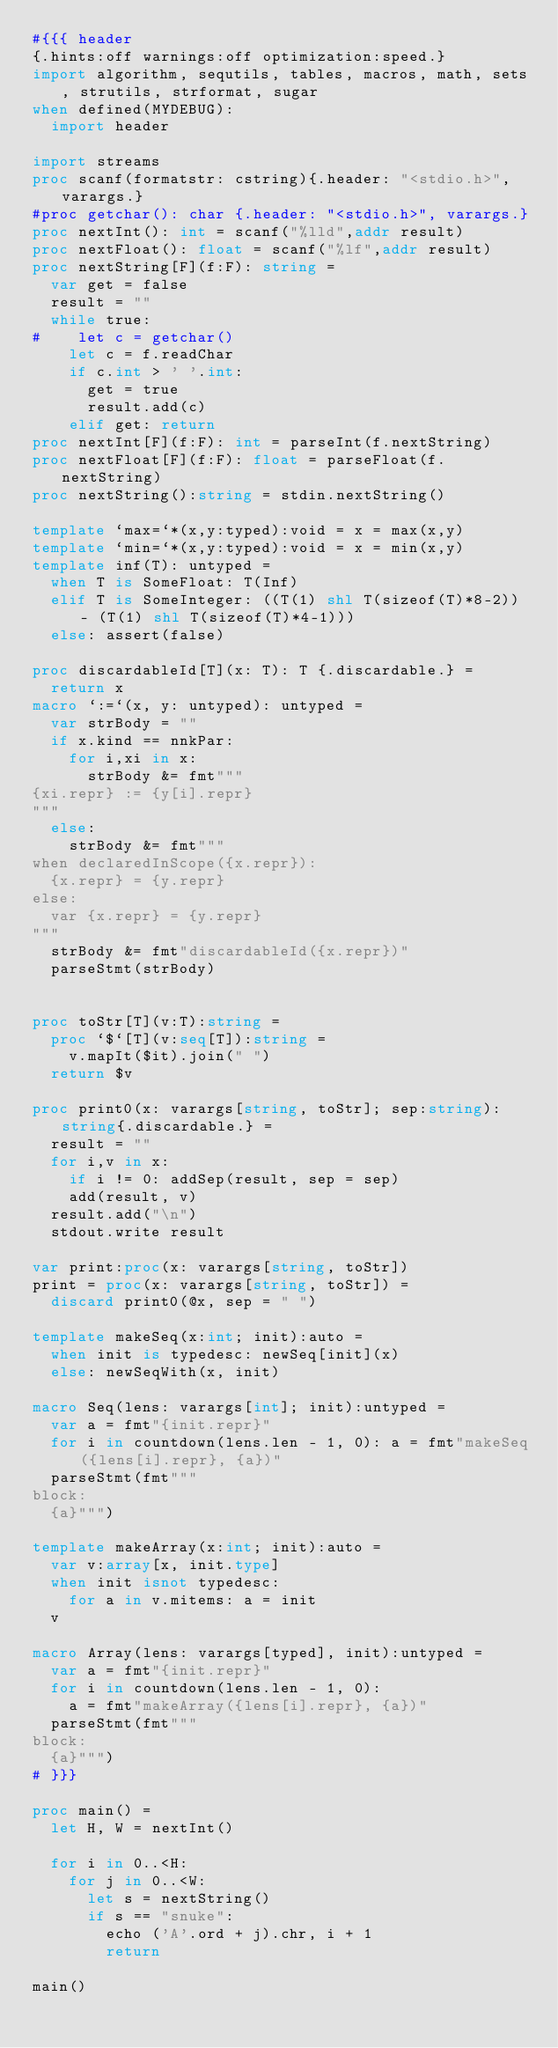Convert code to text. <code><loc_0><loc_0><loc_500><loc_500><_Nim_>#{{{ header
{.hints:off warnings:off optimization:speed.}
import algorithm, sequtils, tables, macros, math, sets, strutils, strformat, sugar
when defined(MYDEBUG):
  import header

import streams
proc scanf(formatstr: cstring){.header: "<stdio.h>", varargs.}
#proc getchar(): char {.header: "<stdio.h>", varargs.}
proc nextInt(): int = scanf("%lld",addr result)
proc nextFloat(): float = scanf("%lf",addr result)
proc nextString[F](f:F): string =
  var get = false
  result = ""
  while true:
#    let c = getchar()
    let c = f.readChar
    if c.int > ' '.int:
      get = true
      result.add(c)
    elif get: return
proc nextInt[F](f:F): int = parseInt(f.nextString)
proc nextFloat[F](f:F): float = parseFloat(f.nextString)
proc nextString():string = stdin.nextString()

template `max=`*(x,y:typed):void = x = max(x,y)
template `min=`*(x,y:typed):void = x = min(x,y)
template inf(T): untyped = 
  when T is SomeFloat: T(Inf)
  elif T is SomeInteger: ((T(1) shl T(sizeof(T)*8-2)) - (T(1) shl T(sizeof(T)*4-1)))
  else: assert(false)

proc discardableId[T](x: T): T {.discardable.} =
  return x
macro `:=`(x, y: untyped): untyped =
  var strBody = ""
  if x.kind == nnkPar:
    for i,xi in x:
      strBody &= fmt"""
{xi.repr} := {y[i].repr}
"""
  else:
    strBody &= fmt"""
when declaredInScope({x.repr}):
  {x.repr} = {y.repr}
else:
  var {x.repr} = {y.repr}
"""
  strBody &= fmt"discardableId({x.repr})"
  parseStmt(strBody)


proc toStr[T](v:T):string =
  proc `$`[T](v:seq[T]):string =
    v.mapIt($it).join(" ")
  return $v

proc print0(x: varargs[string, toStr]; sep:string):string{.discardable.} =
  result = ""
  for i,v in x:
    if i != 0: addSep(result, sep = sep)
    add(result, v)
  result.add("\n")
  stdout.write result

var print:proc(x: varargs[string, toStr])
print = proc(x: varargs[string, toStr]) =
  discard print0(@x, sep = " ")

template makeSeq(x:int; init):auto =
  when init is typedesc: newSeq[init](x)
  else: newSeqWith(x, init)

macro Seq(lens: varargs[int]; init):untyped =
  var a = fmt"{init.repr}"
  for i in countdown(lens.len - 1, 0): a = fmt"makeSeq({lens[i].repr}, {a})"
  parseStmt(fmt"""
block:
  {a}""")

template makeArray(x:int; init):auto =
  var v:array[x, init.type]
  when init isnot typedesc:
    for a in v.mitems: a = init
  v

macro Array(lens: varargs[typed], init):untyped =
  var a = fmt"{init.repr}"
  for i in countdown(lens.len - 1, 0):
    a = fmt"makeArray({lens[i].repr}, {a})"
  parseStmt(fmt"""
block:
  {a}""")
# }}}

proc main() =
  let H, W = nextInt()
  
  for i in 0..<H:
    for j in 0..<W:
      let s = nextString()
      if s == "snuke":
        echo ('A'.ord + j).chr, i + 1
        return

main()</code> 